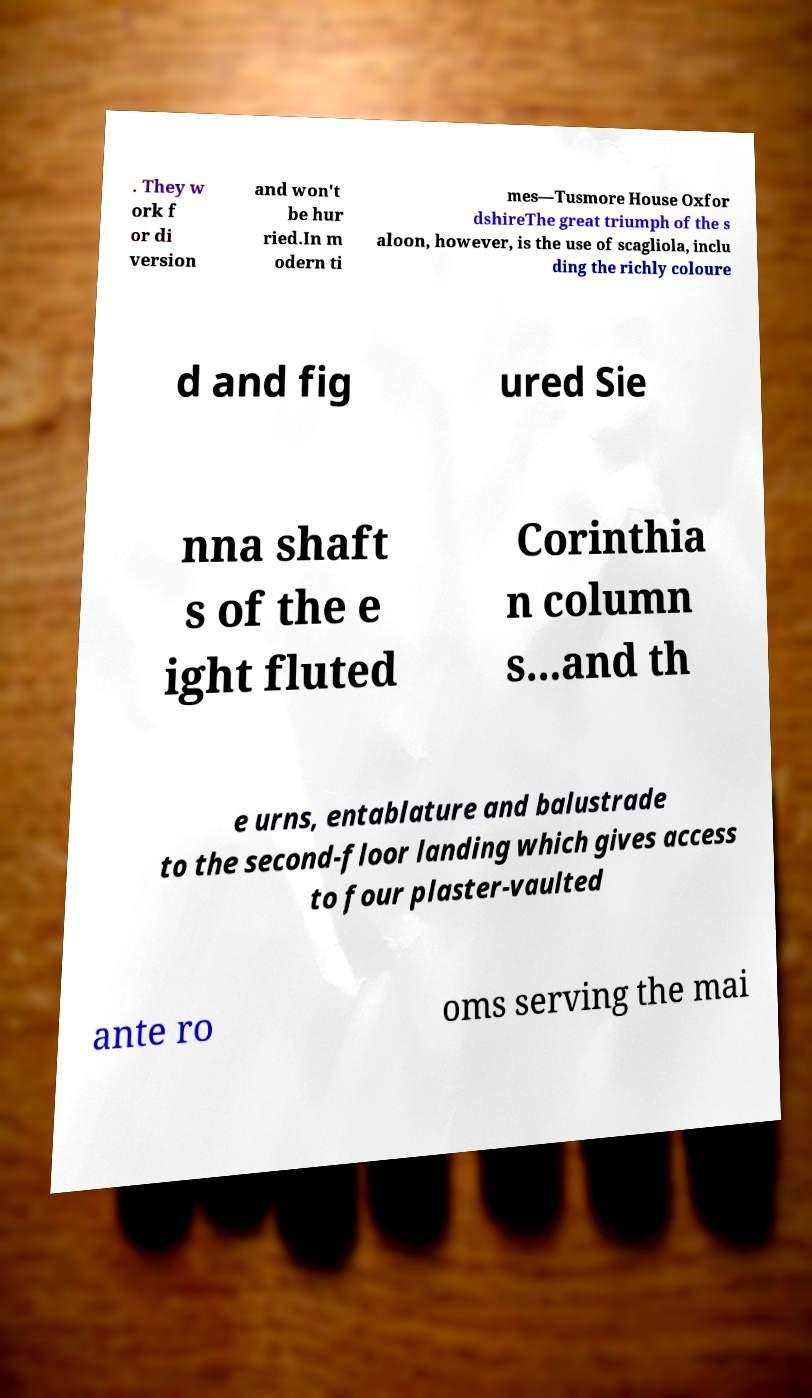Can you accurately transcribe the text from the provided image for me? . They w ork f or di version and won't be hur ried.In m odern ti mes—Tusmore House Oxfor dshireThe great triumph of the s aloon, however, is the use of scagliola, inclu ding the richly coloure d and fig ured Sie nna shaft s of the e ight fluted Corinthia n column s...and th e urns, entablature and balustrade to the second-floor landing which gives access to four plaster-vaulted ante ro oms serving the mai 